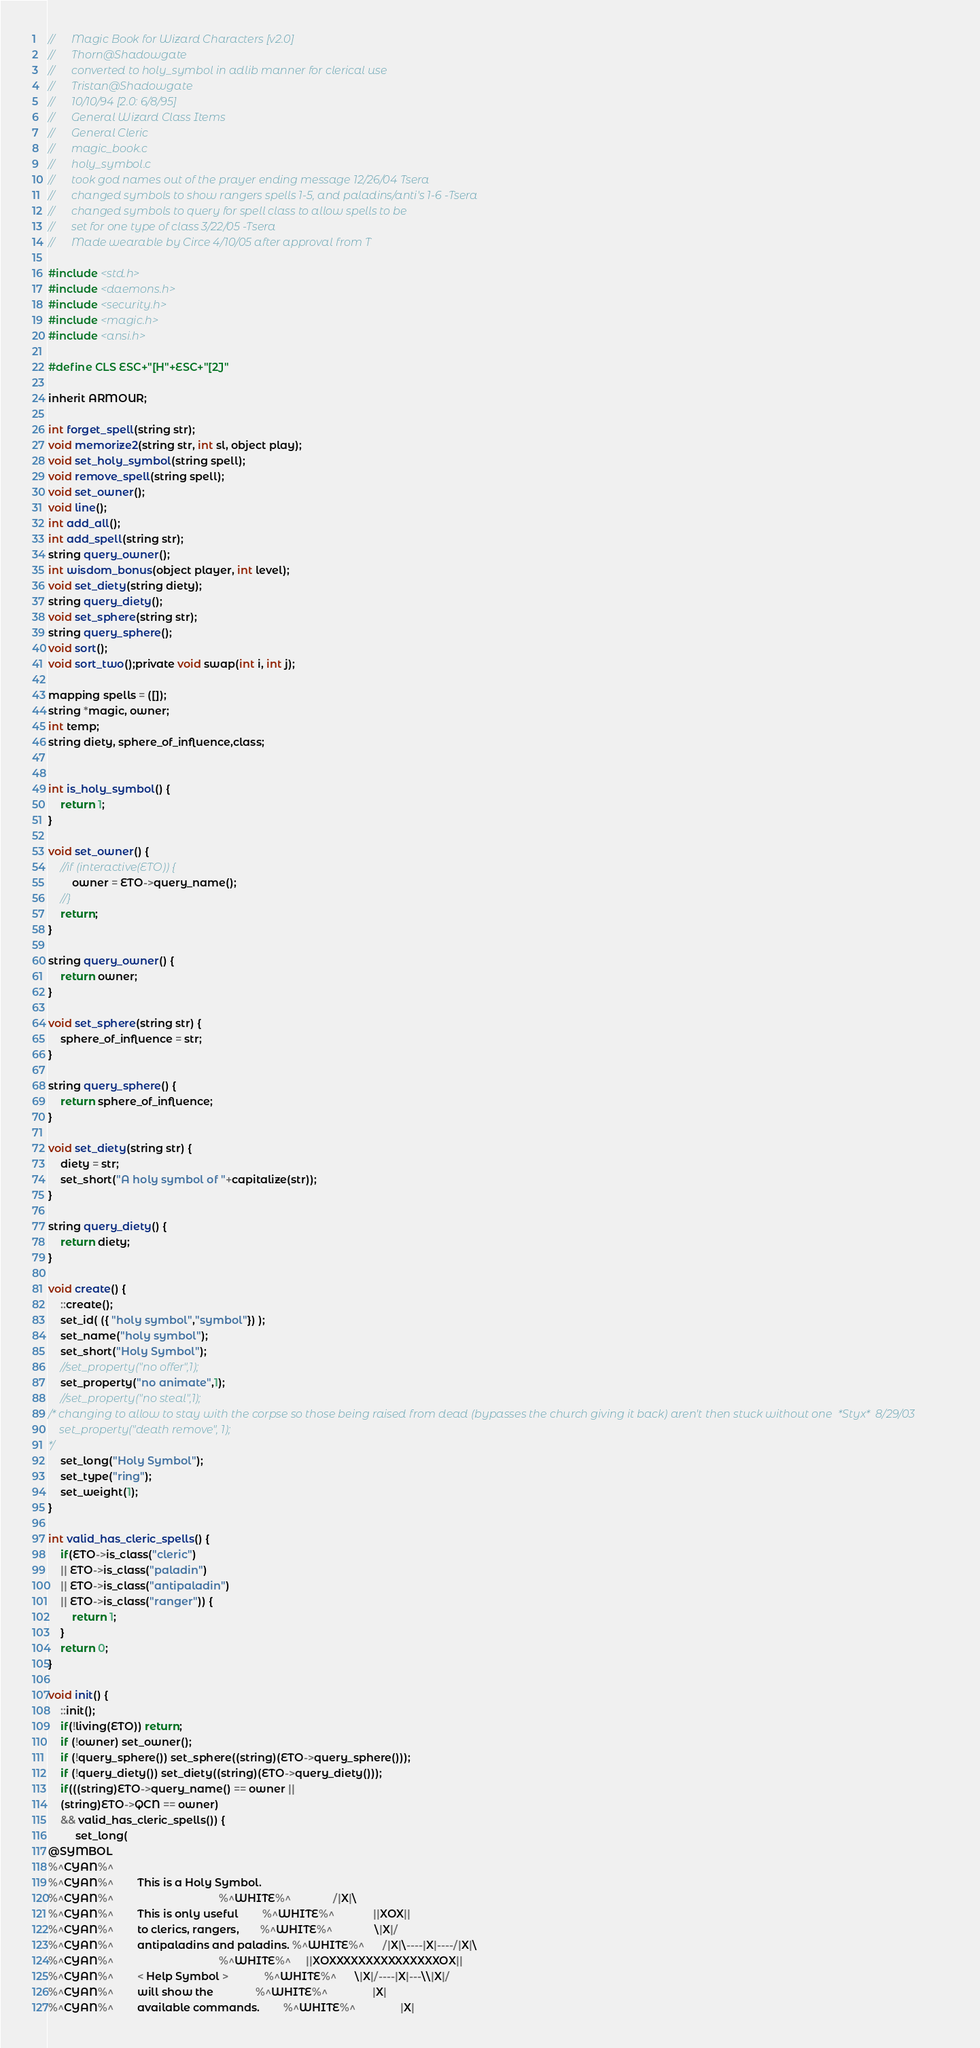<code> <loc_0><loc_0><loc_500><loc_500><_C_>//      Magic Book for Wizard Characters [v2.0]
//      Thorn@Shadowgate
//		converted to holy_symbol in adlib manner for clerical use
//		Tristan@Shadowgate
//      10/10/94 [2.0: 6/8/95]
//      General Wizard Class Items
//		General Cleric
//      magic_book.c
//      holy_symbol.c
//      took god names out of the prayer ending message 12/26/04 Tsera
//      changed symbols to show rangers spells 1-5, and paladins/anti's 1-6 -Tsera
//      changed symbols to query for spell class to allow spells to be 
//      set for one type of class 3/22/05 -Tsera
//      Made wearable by Circe 4/10/05 after approval from T

#include <std.h>
#include <daemons.h>
#include <security.h>
#include <magic.h>
#include <ansi.h>

#define CLS ESC+"[H"+ESC+"[2J"

inherit ARMOUR;

int forget_spell(string str);
void memorize2(string str, int sl, object play);
void set_holy_symbol(string spell);
void remove_spell(string spell);
void set_owner();
void line();
int add_all();
int add_spell(string str);
string query_owner();
int wisdom_bonus(object player, int level);
void set_diety(string diety);
string query_diety();
void set_sphere(string str);
string query_sphere();
void sort();
void sort_two();private void swap(int i, int j);

mapping spells = ([]);
string *magic, owner;
int temp;
string diety, sphere_of_influence,class;


int is_holy_symbol() {
    return 1;
}

void set_owner() {
    //if (interactive(ETO)) {
        owner = ETO->query_name();
    //}
    return;
}

string query_owner() {
    return owner;
}

void set_sphere(string str) {
    sphere_of_influence = str;
}

string query_sphere() {
    return sphere_of_influence;
}

void set_diety(string str) {
    diety = str;
    set_short("A holy symbol of "+capitalize(str));
}

string query_diety() {
    return diety;
}

void create() {
    ::create();
    set_id( ({ "holy symbol","symbol"}) );
    set_name("holy symbol");
    set_short("Holy Symbol");
    //set_property("no offer",1);
    set_property("no animate",1);
    //set_property("no steal",1);
/* changing to allow to stay with the corpse so those being raised from dead (bypasses the church giving it back) aren't then stuck without one  *Styx*  8/29/03
    set_property("death remove", 1);
*/
    set_long("Holy Symbol");
    set_type("ring");
    set_weight(1);
}

int valid_has_cleric_spells() {
    if(ETO->is_class("cleric") 
    || ETO->is_class("paladin")
    || ETO->is_class("antipaladin") 
    || ETO->is_class("ranger")) {
        return 1;
    }
    return 0;
}

void init() {
    ::init();
    if(!living(ETO)) return;
    if (!owner) set_owner();
    if (!query_sphere()) set_sphere((string)(ETO->query_sphere()));
    if (!query_diety()) set_diety((string)(ETO->query_diety()));
    if(((string)ETO->query_name() == owner || 
    (string)ETO->QCN == owner)
    && valid_has_cleric_spells()) {
         set_long(
@SYMBOL
%^CYAN%^
%^CYAN%^        This is a Holy Symbol.
%^CYAN%^                                   %^WHITE%^              /|X|\
%^CYAN%^        This is only useful        %^WHITE%^             ||XOX||
%^CYAN%^        to clerics, rangers,       %^WHITE%^              \|X|/
%^CYAN%^        antipaladins and paladins. %^WHITE%^      /|X|\----|X|----/|X|\
%^CYAN%^                                   %^WHITE%^     ||XOXXXXXXXXXXXXXXXOX||
%^CYAN%^        < Help Symbol >            %^WHITE%^      \|X|/----|X|---\\|X|/
%^CYAN%^        will show the              %^WHITE%^               |X|
%^CYAN%^        available commands.        %^WHITE%^               |X|</code> 